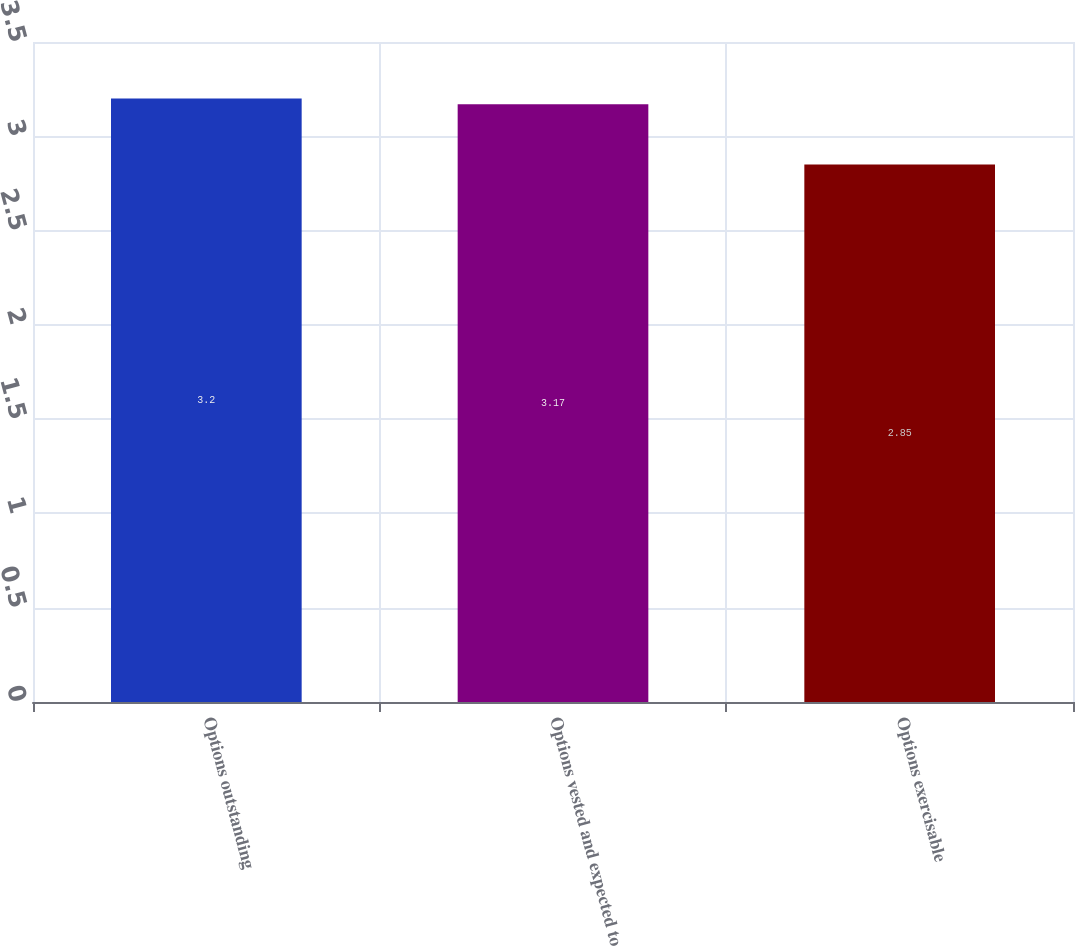<chart> <loc_0><loc_0><loc_500><loc_500><bar_chart><fcel>Options outstanding<fcel>Options vested and expected to<fcel>Options exercisable<nl><fcel>3.2<fcel>3.17<fcel>2.85<nl></chart> 